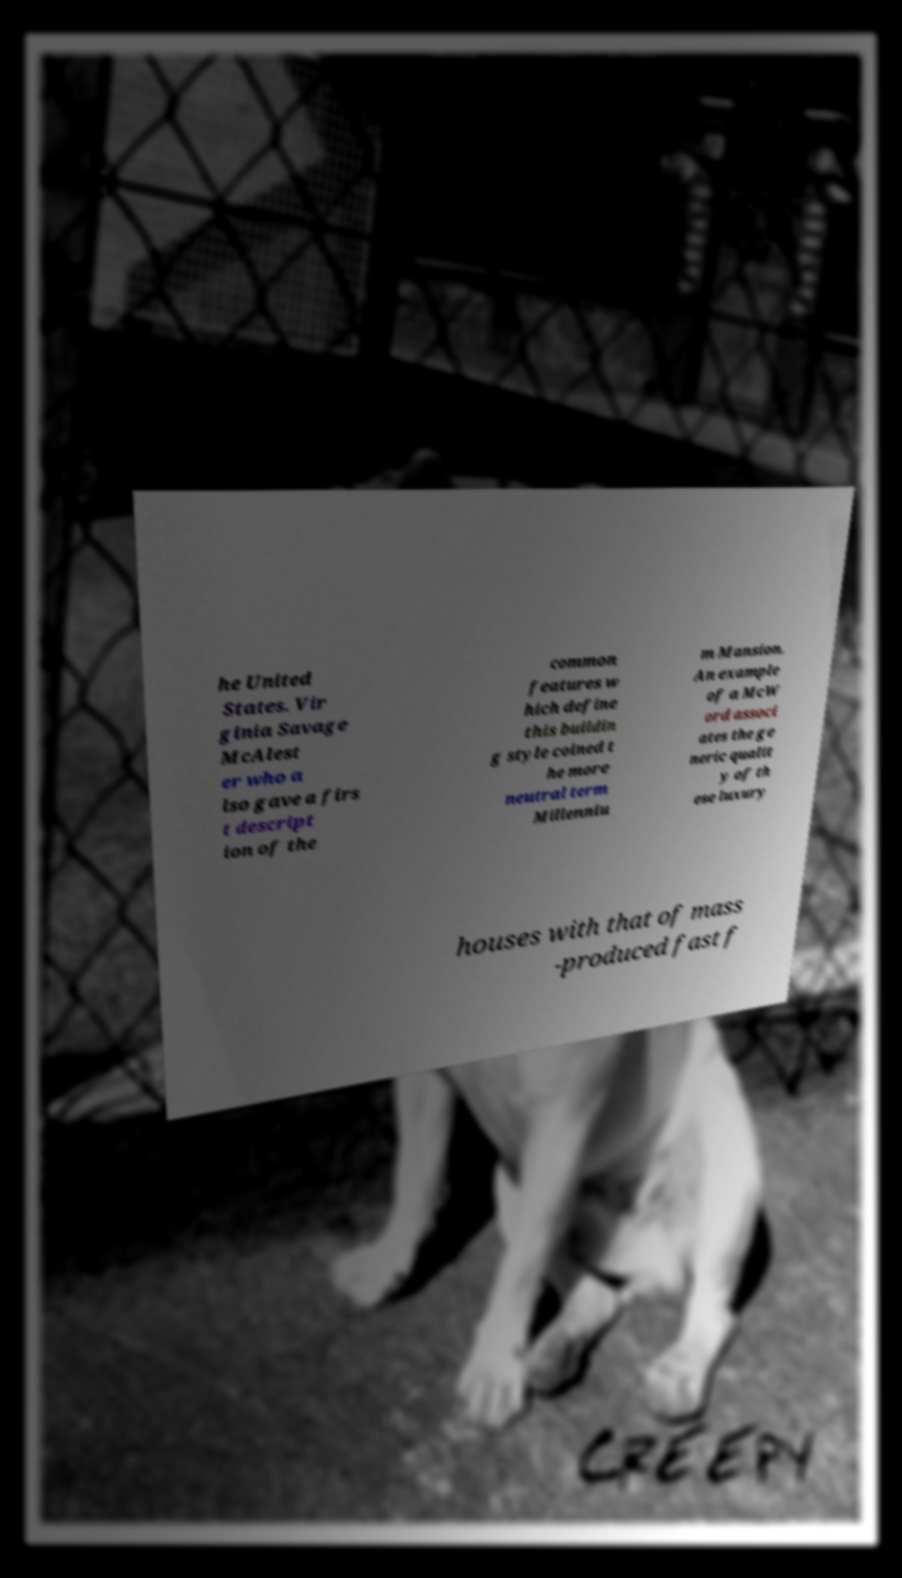I need the written content from this picture converted into text. Can you do that? he United States. Vir ginia Savage McAlest er who a lso gave a firs t descript ion of the common features w hich define this buildin g style coined t he more neutral term Millenniu m Mansion. An example of a McW ord associ ates the ge neric qualit y of th ese luxury houses with that of mass -produced fast f 